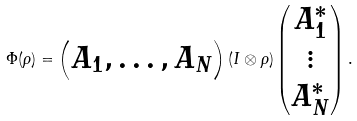Convert formula to latex. <formula><loc_0><loc_0><loc_500><loc_500>\Phi ( \rho ) = \begin{pmatrix} A _ { 1 } , \dots , A _ { N } \end{pmatrix} ( I \otimes \rho ) \begin{pmatrix} A _ { 1 } ^ { \ast } \\ \vdots \\ A _ { N } ^ { \ast } \end{pmatrix} .</formula> 